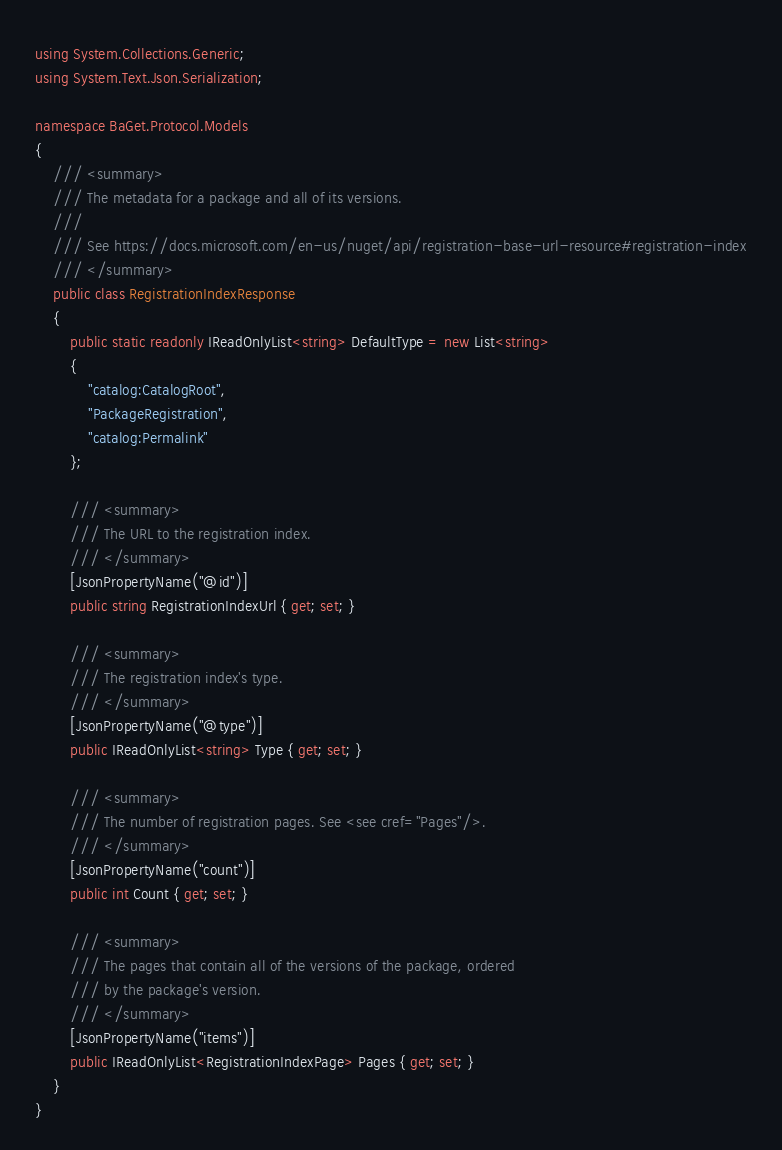Convert code to text. <code><loc_0><loc_0><loc_500><loc_500><_C#_>using System.Collections.Generic;
using System.Text.Json.Serialization;

namespace BaGet.Protocol.Models
{
    /// <summary>
    /// The metadata for a package and all of its versions.
    /// 
    /// See https://docs.microsoft.com/en-us/nuget/api/registration-base-url-resource#registration-index
    /// </summary>
    public class RegistrationIndexResponse
    {
        public static readonly IReadOnlyList<string> DefaultType = new List<string>
        {
            "catalog:CatalogRoot",
            "PackageRegistration",
            "catalog:Permalink"
        };

        /// <summary>
        /// The URL to the registration index.
        /// </summary>
        [JsonPropertyName("@id")]
        public string RegistrationIndexUrl { get; set; }

        /// <summary>
        /// The registration index's type.
        /// </summary>
        [JsonPropertyName("@type")]
        public IReadOnlyList<string> Type { get; set; }

        /// <summary>
        /// The number of registration pages. See <see cref="Pages"/>.
        /// </summary>
        [JsonPropertyName("count")]
        public int Count { get; set; }

        /// <summary>
        /// The pages that contain all of the versions of the package, ordered
        /// by the package's version.
        /// </summary>
        [JsonPropertyName("items")]
        public IReadOnlyList<RegistrationIndexPage> Pages { get; set; }
    }
}
</code> 